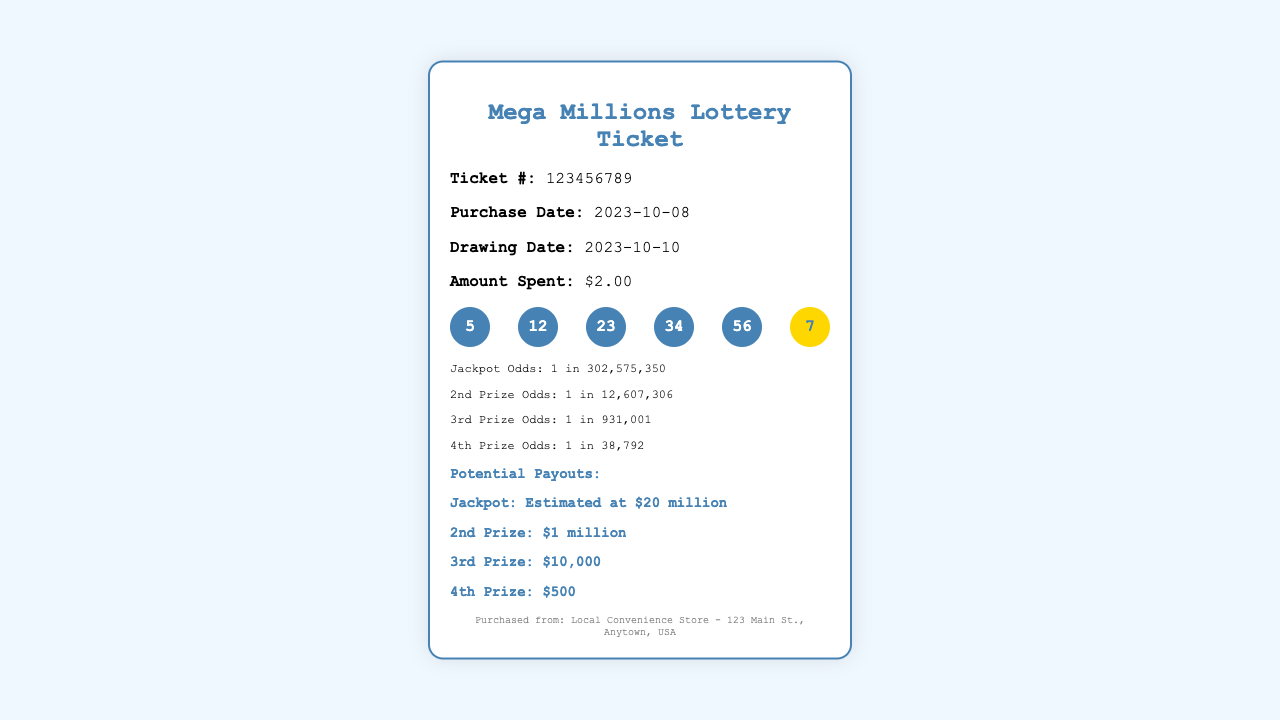what is the ticket number? The ticket number is given in the document as a specific identification for this lottery ticket, which is 123456789.
Answer: 123456789 when was the ticket purchased? The purchase date indicates when the lottery ticket was bought, which is listed as 2023-10-08.
Answer: 2023-10-08 how much did the ticket cost? The amount spent section states the price of the lottery ticket, which is $2.00.
Answer: $2.00 what are the winning numbers? The winning numbers are listed in the document, which include five numbers and one mega number: 5, 12, 23, 34, 56, and 7.
Answer: 5, 12, 23, 34, 56, 7 what is the jackpot odds? The odds of winning the jackpot are provided in the document and are specified as 1 in 302,575,350.
Answer: 1 in 302,575,350 what is the estimated jackpot amount? The potential payouts section states the jackpot amount, which is estimated at $20 million.
Answer: $20 million what is the prize for the second place? The potential payouts detail that the prize for the second place is $1 million.
Answer: $1 million where was the ticket purchased? The footer section provides information about where the ticket was bought, which is a local convenience store at 123 Main St., Anytown, USA.
Answer: Local Convenience Store - 123 Main St., Anytown, USA what is the odds of winning the 4th prize? The odds of winning the 4th prize are mentioned in the odds section as 1 in 38,792.
Answer: 1 in 38,792 